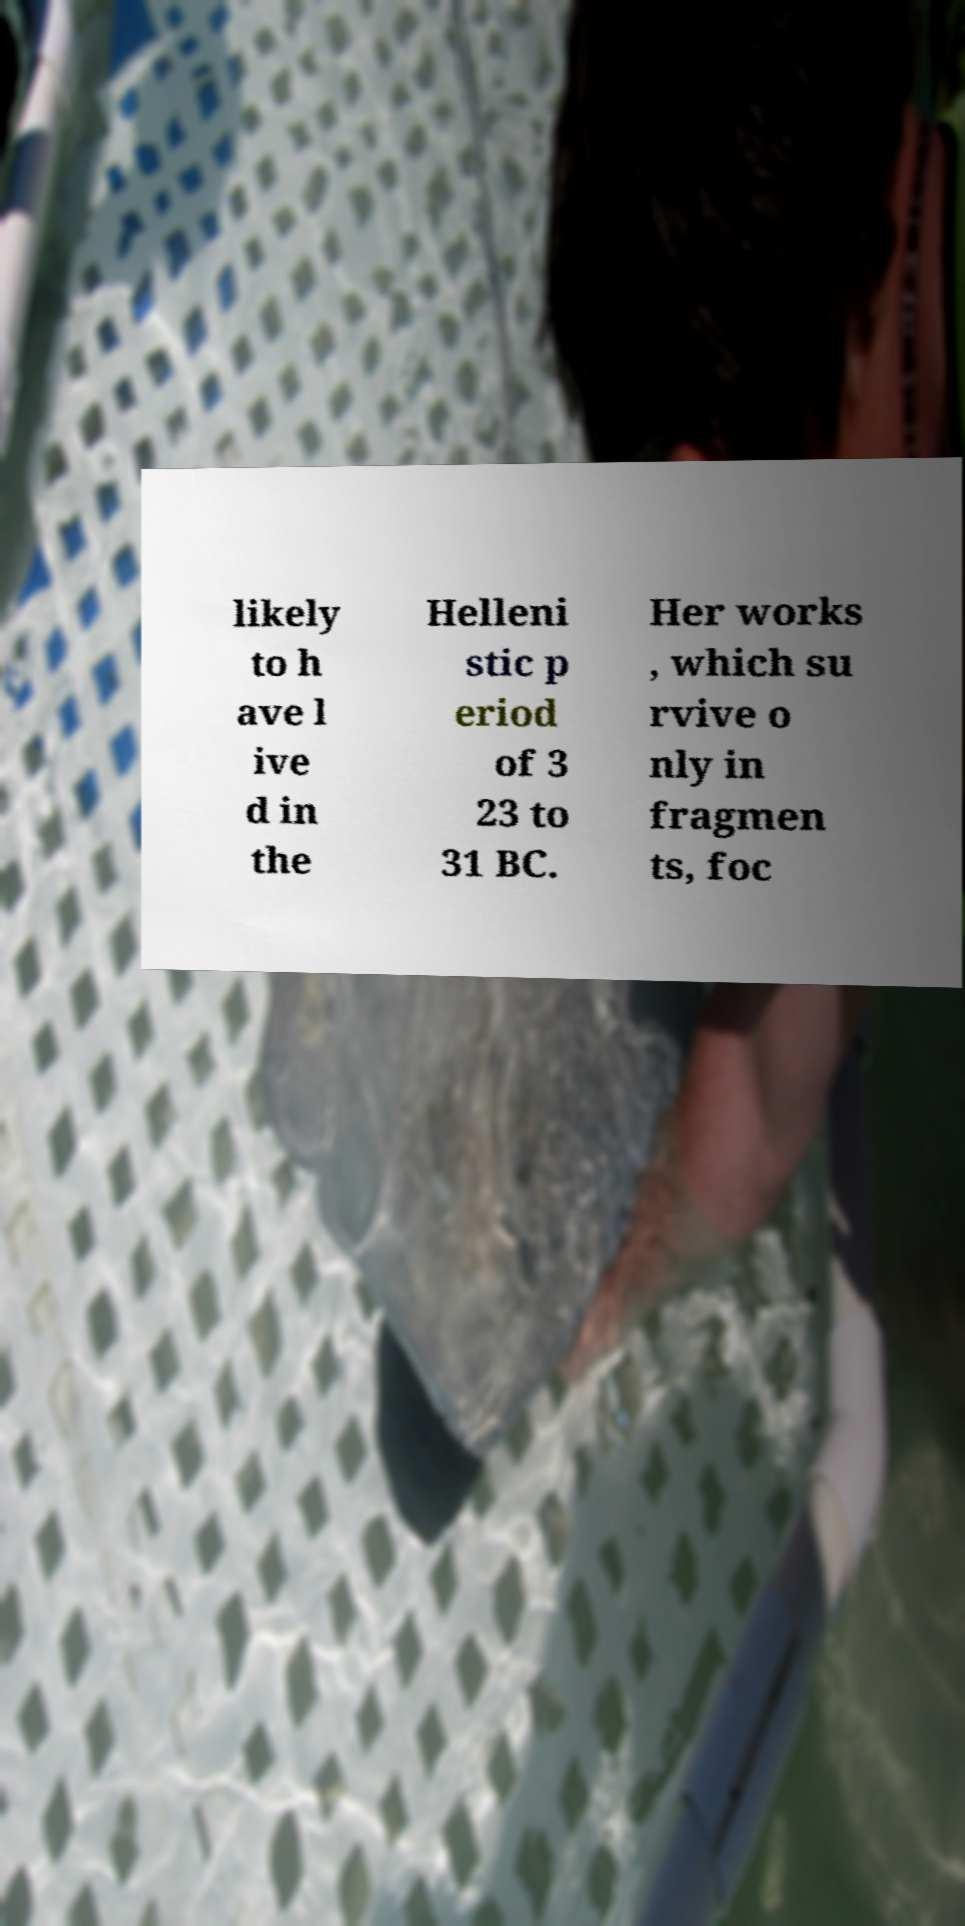Could you extract and type out the text from this image? likely to h ave l ive d in the Helleni stic p eriod of 3 23 to 31 BC. Her works , which su rvive o nly in fragmen ts, foc 